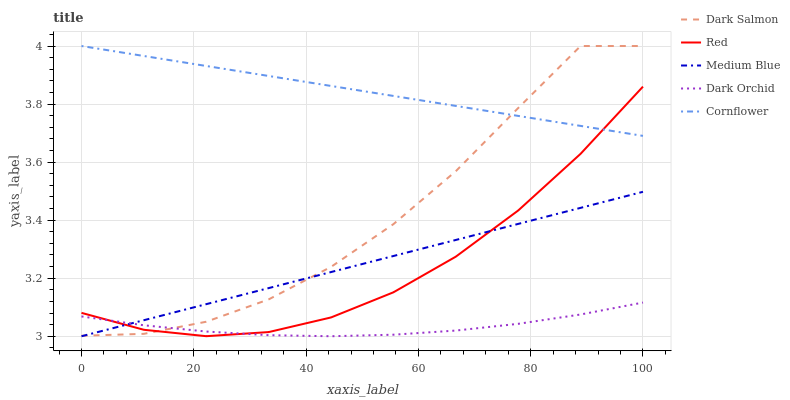Does Dark Orchid have the minimum area under the curve?
Answer yes or no. Yes. Does Cornflower have the maximum area under the curve?
Answer yes or no. Yes. Does Medium Blue have the minimum area under the curve?
Answer yes or no. No. Does Medium Blue have the maximum area under the curve?
Answer yes or no. No. Is Medium Blue the smoothest?
Answer yes or no. Yes. Is Dark Salmon the roughest?
Answer yes or no. Yes. Is Cornflower the smoothest?
Answer yes or no. No. Is Cornflower the roughest?
Answer yes or no. No. Does Medium Blue have the lowest value?
Answer yes or no. Yes. Does Cornflower have the lowest value?
Answer yes or no. No. Does Dark Salmon have the highest value?
Answer yes or no. Yes. Does Medium Blue have the highest value?
Answer yes or no. No. Is Medium Blue less than Cornflower?
Answer yes or no. Yes. Is Cornflower greater than Medium Blue?
Answer yes or no. Yes. Does Medium Blue intersect Dark Salmon?
Answer yes or no. Yes. Is Medium Blue less than Dark Salmon?
Answer yes or no. No. Is Medium Blue greater than Dark Salmon?
Answer yes or no. No. Does Medium Blue intersect Cornflower?
Answer yes or no. No. 